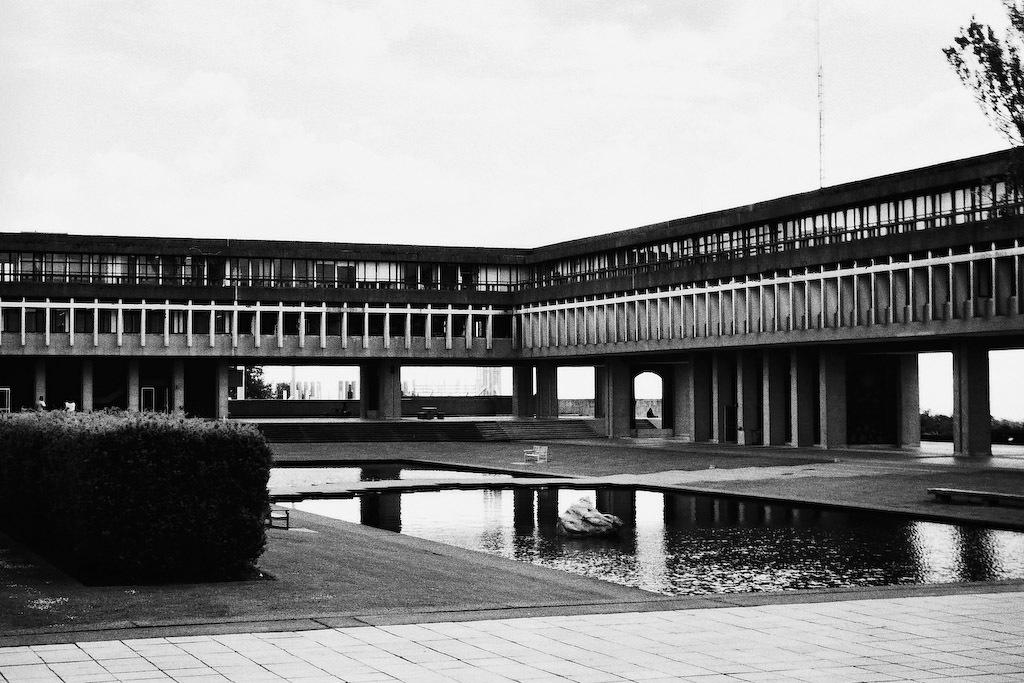What is the color scheme of the image? The image is black and white. What can be seen in the foreground of the image? There is a path in the image. What is visible behind the path? There is a water surface behind the path. What type of structure is present on the water surface? There is some architecture on the water surface. What type of vegetable is growing on the path in the image? There are no vegetables present in the image; it features a path, water surface, and architecture. What direction is the zephyr blowing in the image? There is no mention of a zephyr or wind in the image; it is a still scene. 